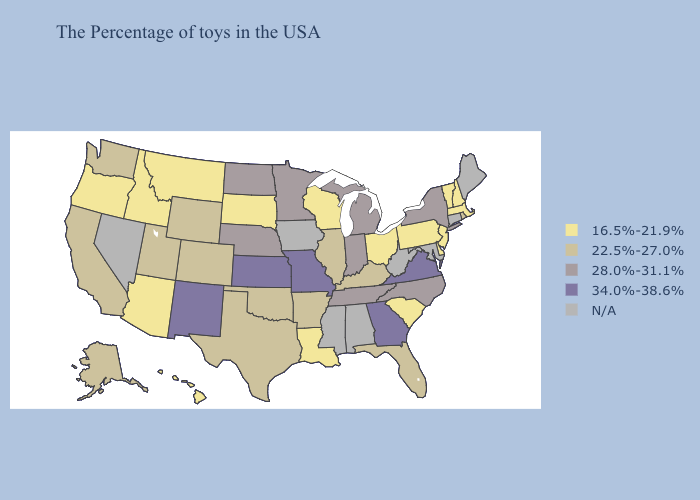What is the lowest value in the South?
Give a very brief answer. 16.5%-21.9%. Name the states that have a value in the range 34.0%-38.6%?
Give a very brief answer. Virginia, Georgia, Missouri, Kansas, New Mexico. Does Georgia have the highest value in the South?
Be succinct. Yes. Which states hav the highest value in the West?
Short answer required. New Mexico. What is the value of Pennsylvania?
Give a very brief answer. 16.5%-21.9%. Which states hav the highest value in the Northeast?
Short answer required. New York. What is the lowest value in the USA?
Answer briefly. 16.5%-21.9%. What is the value of Wyoming?
Keep it brief. 22.5%-27.0%. Name the states that have a value in the range 22.5%-27.0%?
Short answer required. Rhode Island, Florida, Kentucky, Illinois, Arkansas, Oklahoma, Texas, Wyoming, Colorado, Utah, California, Washington, Alaska. Name the states that have a value in the range 34.0%-38.6%?
Short answer required. Virginia, Georgia, Missouri, Kansas, New Mexico. Name the states that have a value in the range 34.0%-38.6%?
Write a very short answer. Virginia, Georgia, Missouri, Kansas, New Mexico. What is the value of Louisiana?
Quick response, please. 16.5%-21.9%. Name the states that have a value in the range 28.0%-31.1%?
Concise answer only. New York, North Carolina, Michigan, Indiana, Tennessee, Minnesota, Nebraska, North Dakota. What is the value of Idaho?
Answer briefly. 16.5%-21.9%. Name the states that have a value in the range 22.5%-27.0%?
Give a very brief answer. Rhode Island, Florida, Kentucky, Illinois, Arkansas, Oklahoma, Texas, Wyoming, Colorado, Utah, California, Washington, Alaska. 